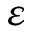<formula> <loc_0><loc_0><loc_500><loc_500>\varepsilon</formula> 